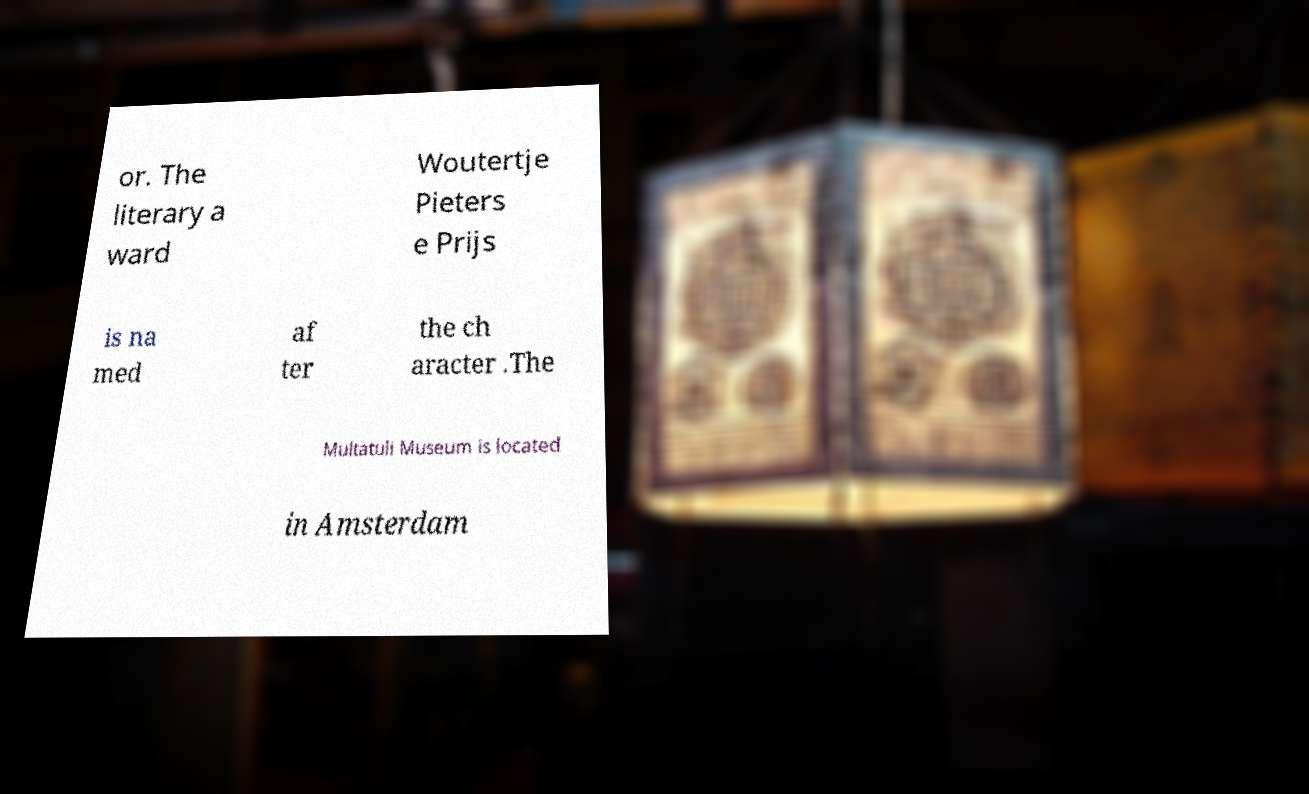Please read and relay the text visible in this image. What does it say? or. The literary a ward Woutertje Pieters e Prijs is na med af ter the ch aracter .The Multatuli Museum is located in Amsterdam 